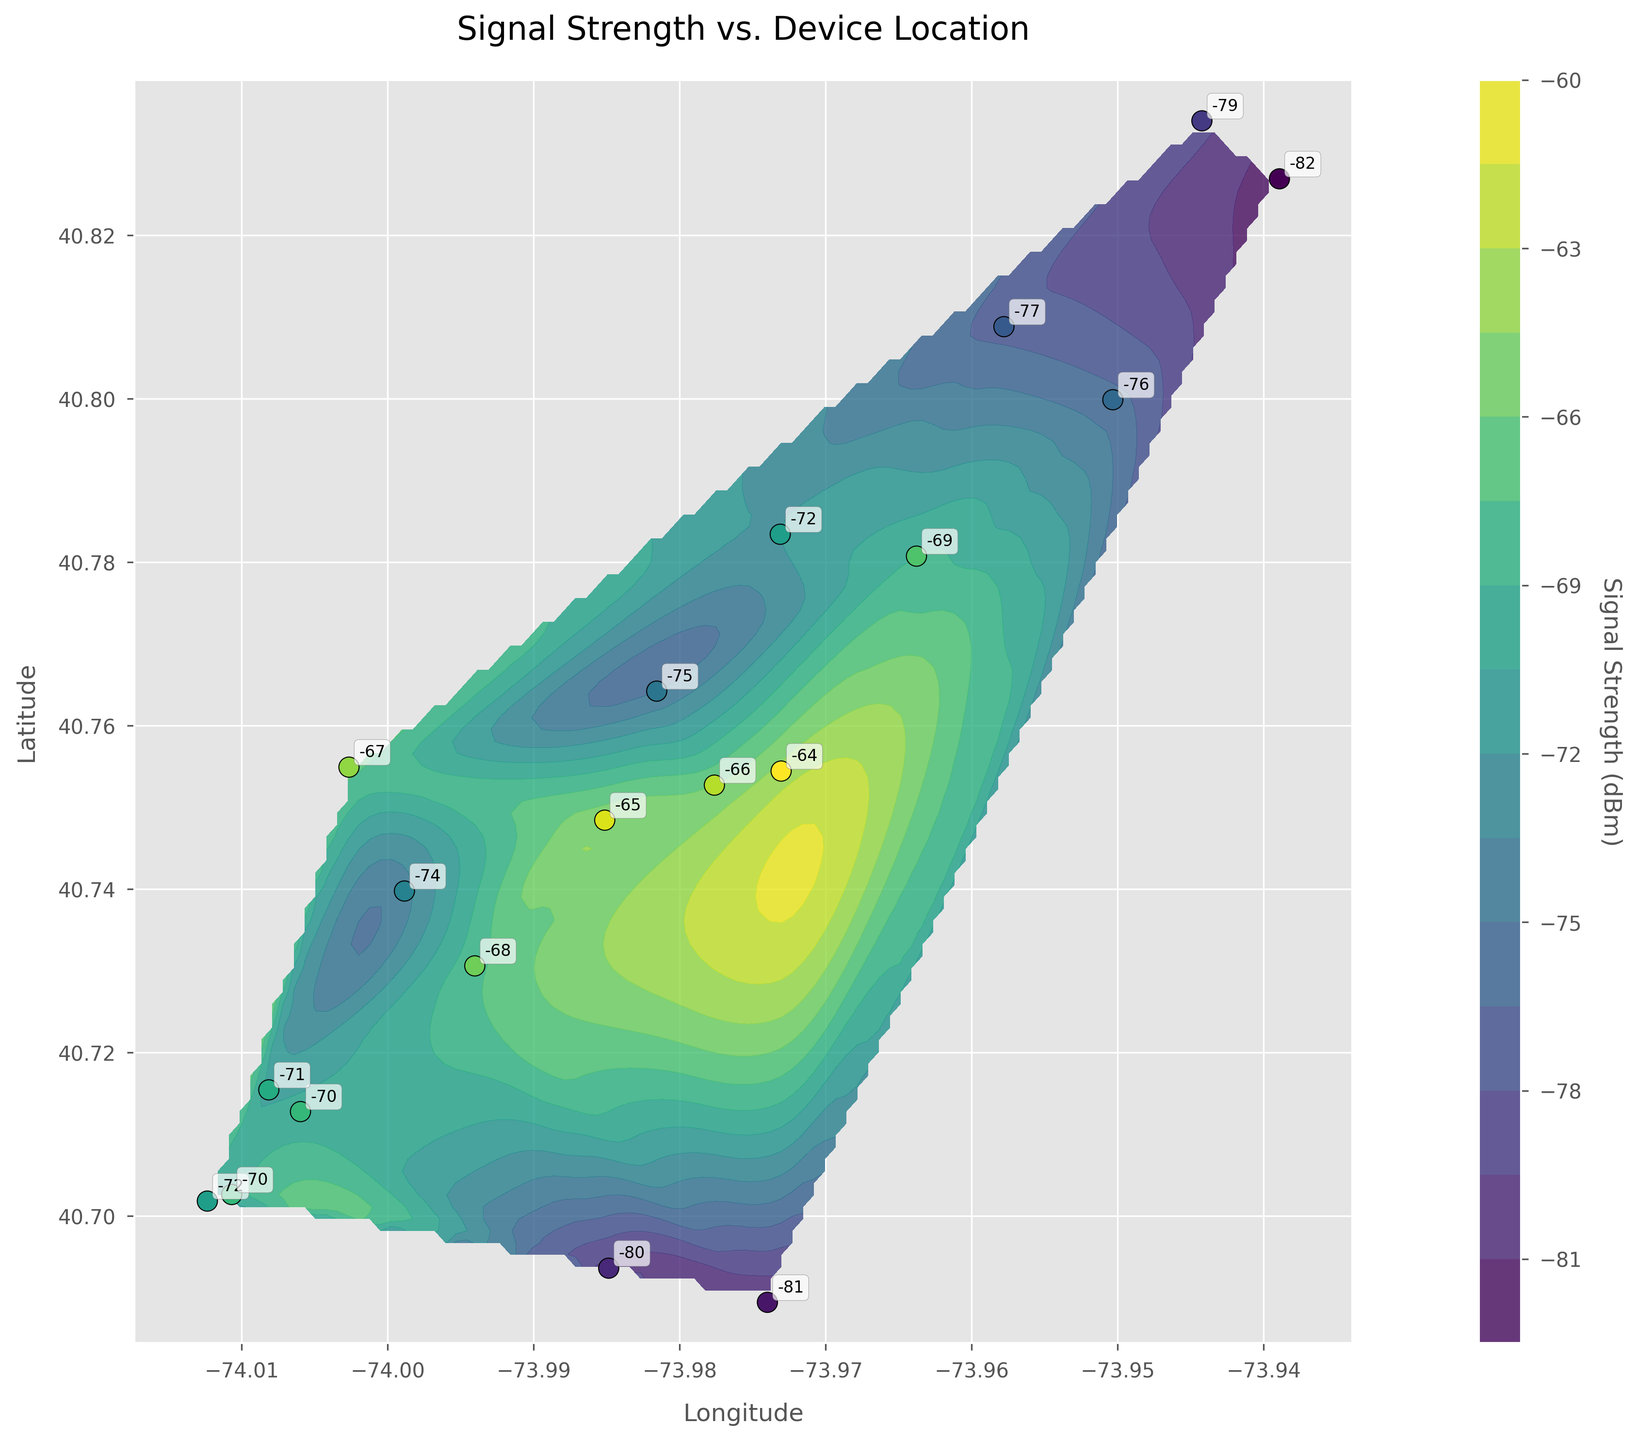What is the title of the plot? The title can be found at the top of the figure in a larger font compared to other text. It describes the main content of the plot.
Answer: Signal Strength vs. Device Location What does the color bar represent in this plot? The color bar is located on the side of the plot and indicates what the colors in the plot correspond to. It helps in reading the signal strength values.
Answer: Signal Strength (dBm) How many data points are there in this plot? By counting the number of scatter points (usually marked with a different color or symbol) plotted on the contour, you can determine the total number of data points.
Answer: 19 Which longitude has the weakest signal strength and what is its value? Look for the scatter point with the lowest signal strength (color corresponding to weakest on the color bar) and read the respective longitude from the annotations or the point position on the plot.
Answer: -73.93892, -82 dBm Where is the signal strength -70 dBm located? Identify the points marked with -70 dBm annotation on the contour plot and find the longitude and latitude.
Answer: Longitude: -74.00597, Latitude: 40.71278 Which location has the strongest signal strength and what is the value? Look for the point with the highest signal strength annotation on the plot and read the specific value from the figure.
Answer: -73.97305, 40.75445, -64 dBm What is the average signal strength of all data points? Sum all the signal strength values given in the annotations or data points and then divide by the number of data points. This involves addition and division operations.
Answer: (-70 + -65 + -75 + -72 + -68 + -72 + -82 + -77 + -69 + -80 + -66 + -71 + -79 + -67 + -81 + -74 + -64 + -76 + -70)/19 = -72.26 dBm Compare the signal strength at Longitude -74.00814, Latitude 40.71544 with the signal strength at Longitude -73.97305, Latitude 40.75445. Which is stronger? Identify the two points on the plot using annotations, then compare their corresponding signal strength values directly.
Answer: -73.97305, 40.75445 (-64 dBm) is stronger What is the geographical area covered by the plot? Examine the x-axis and y-axis ranges for longitudes and latitudes, determining the minimum and maximum values covered in the plot.
Answer: Longitude: -74.01235 to -73.93892, Latitude: 40.68944 to 40.83402 Identify the area with the most uniform signal strength. Look for regions in the contour plot where the colors are similar and continuous, indicating uniform signal strength, and mention the approximate longitude and latitude range.
Answer: Around Longitude -73.98513, Latitude 40.74844 to Longitude -73.98157, Latitude 40.76423 